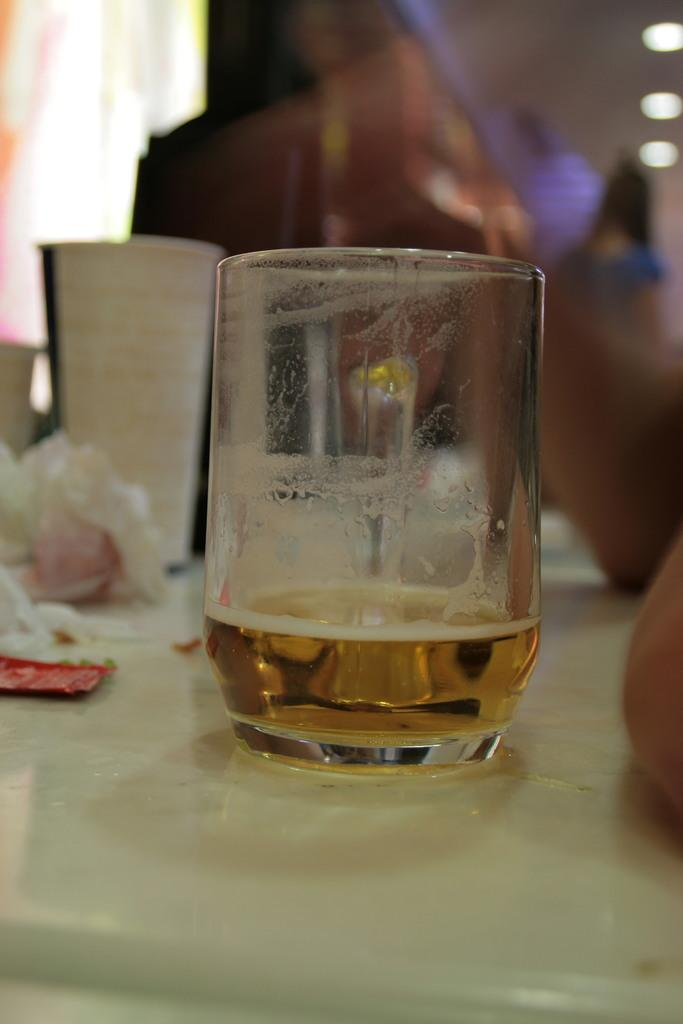Where is the image taken? The image is taken in a room. What furniture is present in the room? There is a table in the room. What objects are on the table? There is a glass, a cup, tissues, and other items on the table. What is the condition of the area behind the glass? The area behind the glass is blurred. What type of lighting is present in the room? There are ceiling lights in the room. What type of wine is being served in the glass in the image? There is no wine present in the image; only a glass, a cup, tissues, and other items are visible on the table. What angle is the camera positioned at in the image? The angle of the camera is not mentioned in the provided facts, so it cannot be determined from the image. 